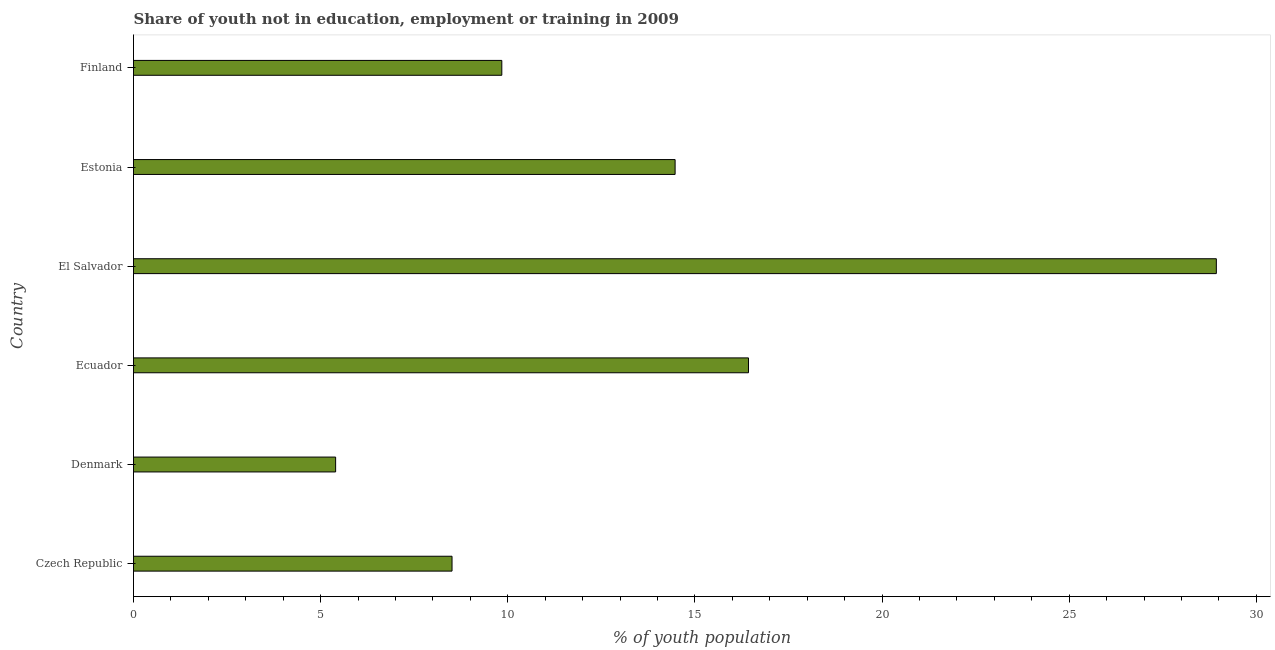Does the graph contain grids?
Make the answer very short. No. What is the title of the graph?
Offer a terse response. Share of youth not in education, employment or training in 2009. What is the label or title of the X-axis?
Your answer should be very brief. % of youth population. What is the label or title of the Y-axis?
Offer a terse response. Country. What is the unemployed youth population in Denmark?
Make the answer very short. 5.4. Across all countries, what is the maximum unemployed youth population?
Give a very brief answer. 28.93. Across all countries, what is the minimum unemployed youth population?
Ensure brevity in your answer.  5.4. In which country was the unemployed youth population maximum?
Ensure brevity in your answer.  El Salvador. What is the sum of the unemployed youth population?
Make the answer very short. 83.58. What is the difference between the unemployed youth population in Czech Republic and Estonia?
Provide a short and direct response. -5.96. What is the average unemployed youth population per country?
Ensure brevity in your answer.  13.93. What is the median unemployed youth population?
Your answer should be very brief. 12.16. In how many countries, is the unemployed youth population greater than 21 %?
Your answer should be compact. 1. What is the ratio of the unemployed youth population in Denmark to that in Ecuador?
Your answer should be very brief. 0.33. Is the difference between the unemployed youth population in Czech Republic and El Salvador greater than the difference between any two countries?
Your answer should be compact. No. What is the difference between the highest and the lowest unemployed youth population?
Ensure brevity in your answer.  23.53. How many bars are there?
Provide a succinct answer. 6. Are all the bars in the graph horizontal?
Your answer should be very brief. Yes. How many countries are there in the graph?
Keep it short and to the point. 6. What is the % of youth population in Czech Republic?
Keep it short and to the point. 8.51. What is the % of youth population of Denmark?
Give a very brief answer. 5.4. What is the % of youth population of Ecuador?
Offer a terse response. 16.43. What is the % of youth population of El Salvador?
Make the answer very short. 28.93. What is the % of youth population of Estonia?
Offer a terse response. 14.47. What is the % of youth population in Finland?
Offer a very short reply. 9.84. What is the difference between the % of youth population in Czech Republic and Denmark?
Ensure brevity in your answer.  3.11. What is the difference between the % of youth population in Czech Republic and Ecuador?
Ensure brevity in your answer.  -7.92. What is the difference between the % of youth population in Czech Republic and El Salvador?
Provide a short and direct response. -20.42. What is the difference between the % of youth population in Czech Republic and Estonia?
Give a very brief answer. -5.96. What is the difference between the % of youth population in Czech Republic and Finland?
Make the answer very short. -1.33. What is the difference between the % of youth population in Denmark and Ecuador?
Your answer should be very brief. -11.03. What is the difference between the % of youth population in Denmark and El Salvador?
Give a very brief answer. -23.53. What is the difference between the % of youth population in Denmark and Estonia?
Ensure brevity in your answer.  -9.07. What is the difference between the % of youth population in Denmark and Finland?
Offer a very short reply. -4.44. What is the difference between the % of youth population in Ecuador and El Salvador?
Offer a terse response. -12.5. What is the difference between the % of youth population in Ecuador and Estonia?
Make the answer very short. 1.96. What is the difference between the % of youth population in Ecuador and Finland?
Provide a succinct answer. 6.59. What is the difference between the % of youth population in El Salvador and Estonia?
Make the answer very short. 14.46. What is the difference between the % of youth population in El Salvador and Finland?
Give a very brief answer. 19.09. What is the difference between the % of youth population in Estonia and Finland?
Provide a short and direct response. 4.63. What is the ratio of the % of youth population in Czech Republic to that in Denmark?
Your answer should be very brief. 1.58. What is the ratio of the % of youth population in Czech Republic to that in Ecuador?
Make the answer very short. 0.52. What is the ratio of the % of youth population in Czech Republic to that in El Salvador?
Your response must be concise. 0.29. What is the ratio of the % of youth population in Czech Republic to that in Estonia?
Your response must be concise. 0.59. What is the ratio of the % of youth population in Czech Republic to that in Finland?
Make the answer very short. 0.86. What is the ratio of the % of youth population in Denmark to that in Ecuador?
Offer a very short reply. 0.33. What is the ratio of the % of youth population in Denmark to that in El Salvador?
Keep it short and to the point. 0.19. What is the ratio of the % of youth population in Denmark to that in Estonia?
Provide a short and direct response. 0.37. What is the ratio of the % of youth population in Denmark to that in Finland?
Make the answer very short. 0.55. What is the ratio of the % of youth population in Ecuador to that in El Salvador?
Provide a short and direct response. 0.57. What is the ratio of the % of youth population in Ecuador to that in Estonia?
Offer a terse response. 1.14. What is the ratio of the % of youth population in Ecuador to that in Finland?
Keep it short and to the point. 1.67. What is the ratio of the % of youth population in El Salvador to that in Estonia?
Provide a short and direct response. 2. What is the ratio of the % of youth population in El Salvador to that in Finland?
Provide a succinct answer. 2.94. What is the ratio of the % of youth population in Estonia to that in Finland?
Offer a very short reply. 1.47. 